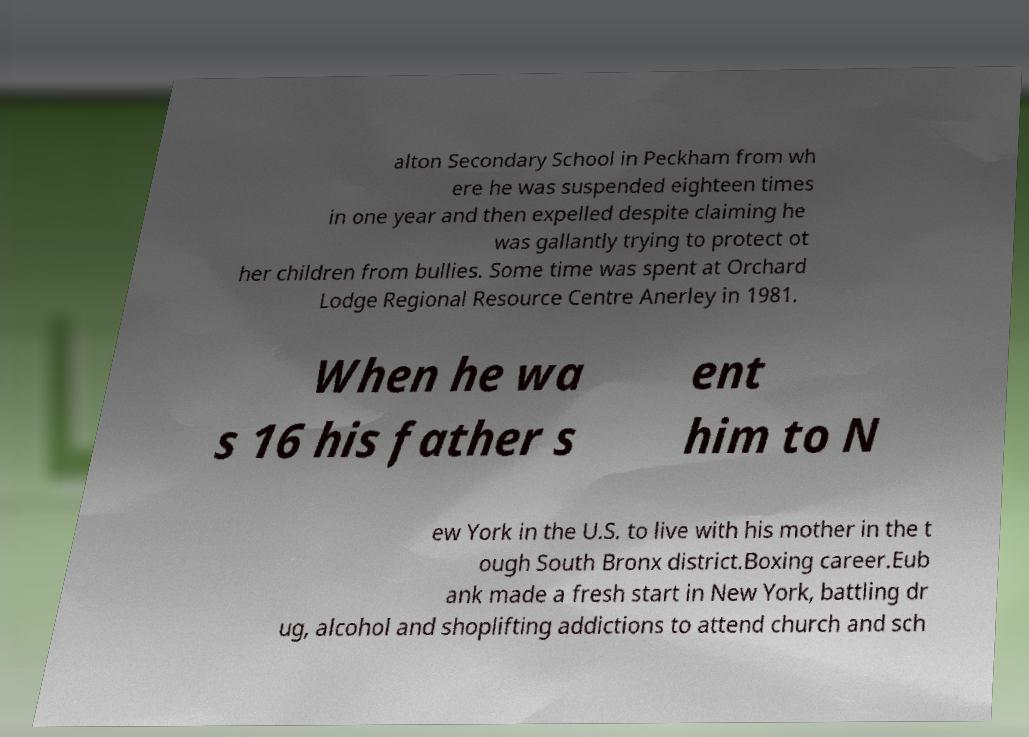Could you assist in decoding the text presented in this image and type it out clearly? alton Secondary School in Peckham from wh ere he was suspended eighteen times in one year and then expelled despite claiming he was gallantly trying to protect ot her children from bullies. Some time was spent at Orchard Lodge Regional Resource Centre Anerley in 1981. When he wa s 16 his father s ent him to N ew York in the U.S. to live with his mother in the t ough South Bronx district.Boxing career.Eub ank made a fresh start in New York, battling dr ug, alcohol and shoplifting addictions to attend church and sch 